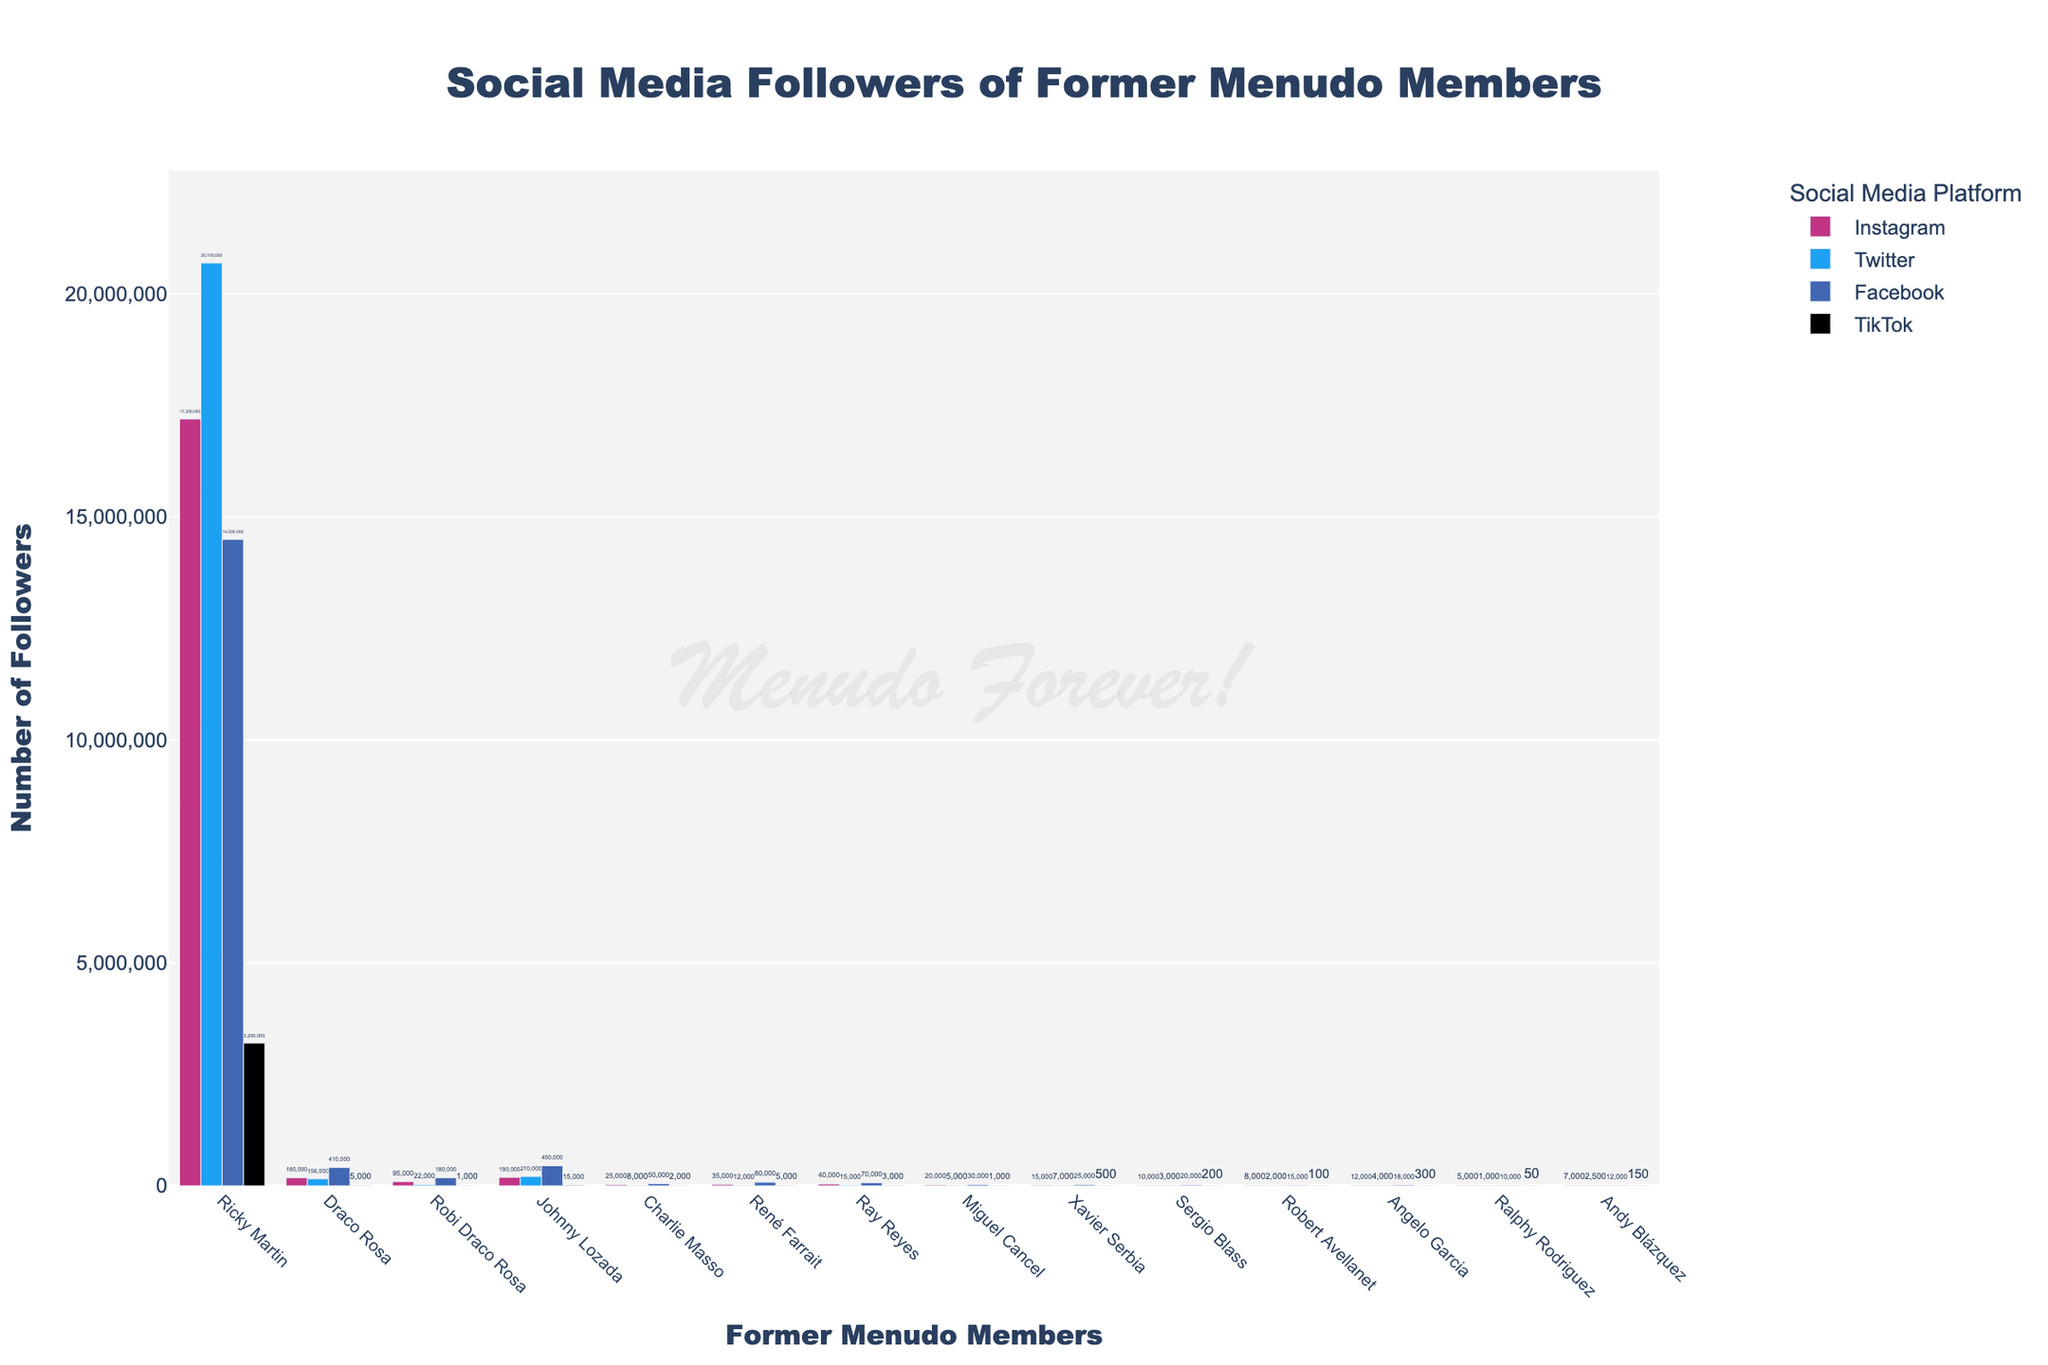Which former Menudo member has the most followers on Facebook? By looking at the bars labeled “Facebook” and identifying the tallest bar within that section, we can see that Ricky Martin has the highest follower count on Facebook.
Answer: Ricky Martin Who has more followers on Instagram, Johnny Lozada or Robi Draco Rosa? Compare the heights of the Instagram bars for Johnny Lozada and Robi Draco Rosa. Johnny Lozada's Instagram bar is higher than Robi Draco Rosa's.
Answer: Johnny Lozada Which social media platform does Draco Rosa have the least followers on? Identify the shortest bar among the bars for Draco Rosa across all platforms. The TikTok bar for Draco Rosa is the shortest.
Answer: TikTok What is the total number of TikTok followers for René Farrait and Miguel Cancel? Add the number of TikTok followers for René Farrait and Miguel Cancel: 5000 for René Farrait and 1000 for Miguel Cancel, which gives a total of 6000 followers.
Answer: 6000 Which former Menudo member has the second-highest follower count on Twitter? Exclude the member with the highest follower count, Ricky Martin, and look for the next highest Twitter bar. Johnny Lozada's Twitter bar is the second highest.
Answer: Johnny Lozada Who has more total followers across all platforms, Charlie Masso or Ray Reyes? Sum the follower counts across all platforms for Charlie Masso (25,000 Instagram + 8,000 Twitter + 50,000 Facebook + 2,000 TikTok = 85,000) and Ray Reyes (40,000 Instagram + 15,000 Twitter + 70,000 Facebook + 3,000 TikTok = 128,000) and compare them. Ray Reyes has more total followers.
Answer: Ray Reyes Which social media platform generally has the least followers for most of the former Menudo members? Observe the relative heights of bars for all platforms across all members. The TikTok bars are generally the shortest compared to the others.
Answer: TikTok What is the difference in the number of Instagram followers between Ricky Martin and Draco Rosa? Subtract Draco Rosa's Instagram followers (180,000) from Ricky Martin's Instagram followers (17,200,000): 17,200,000 - 180,000 = 17,020,000.
Answer: 17,020,000 Which former Menudo member has around 20,000 Instagram followers? Look for the bar in the Instagram section that is closest to 20,000 followers. Miguel Cancel has 20,000 Instagram followers.
Answer: Miguel Cancel 